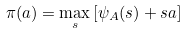Convert formula to latex. <formula><loc_0><loc_0><loc_500><loc_500>\pi ( a ) = \max _ { s } \left [ \psi _ { A } ( s ) + s a \right ]</formula> 